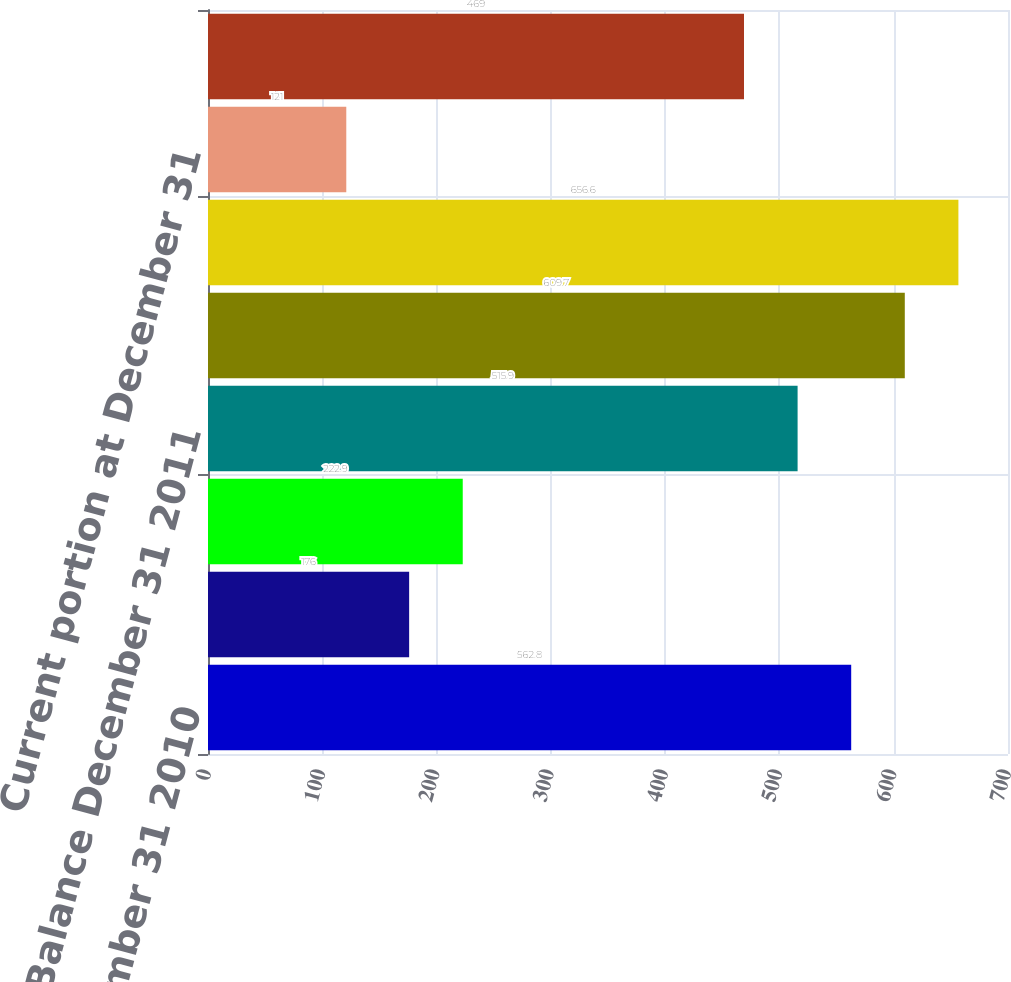Convert chart to OTSL. <chart><loc_0><loc_0><loc_500><loc_500><bar_chart><fcel>Balance December 31 2010<fcel>Self-insurance expense<fcel>Cash (paid) received<fcel>Balance December 31 2011<fcel>Balance December 31 2012<fcel>Balance December 31 2013(b)<fcel>Current portion at December 31<fcel>Long-term portion at December<nl><fcel>562.8<fcel>176<fcel>222.9<fcel>515.9<fcel>609.7<fcel>656.6<fcel>121<fcel>469<nl></chart> 